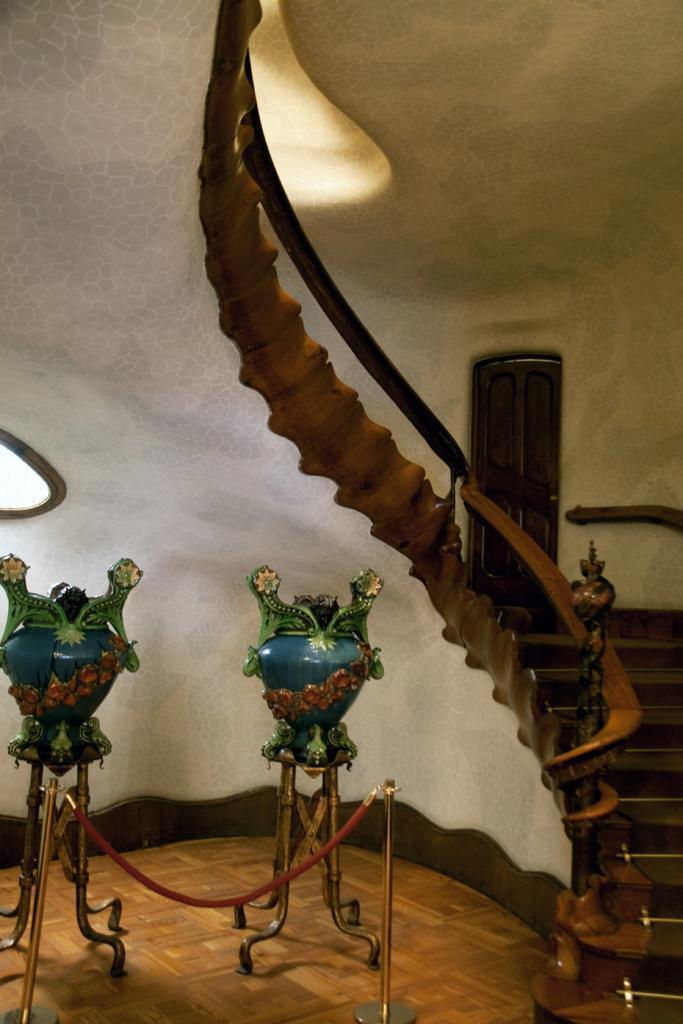Please provide a concise description of this image. In this image there are two flower vases on a floor and there are two safety poles, on the right side there are stairs and a railing, in the background there is a wall, for that wall there is a door. 